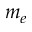Convert formula to latex. <formula><loc_0><loc_0><loc_500><loc_500>m _ { e }</formula> 